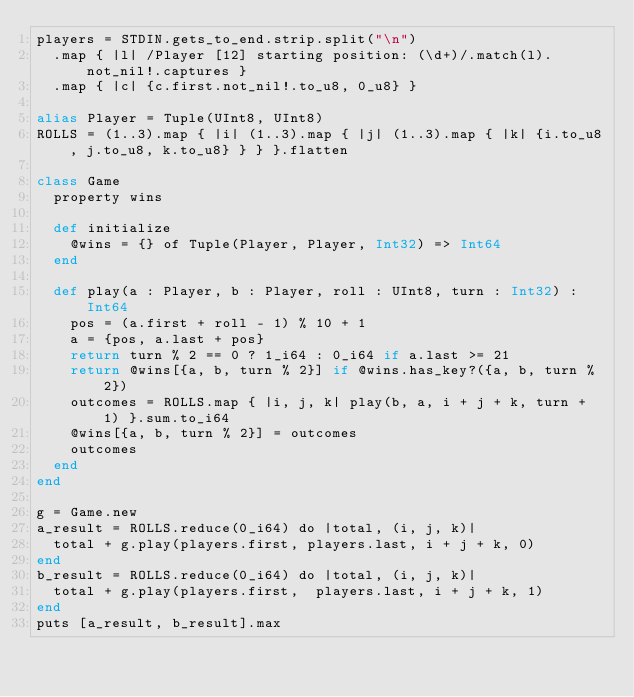Convert code to text. <code><loc_0><loc_0><loc_500><loc_500><_Crystal_>players = STDIN.gets_to_end.strip.split("\n")
  .map { |l| /Player [12] starting position: (\d+)/.match(l).not_nil!.captures }
  .map { |c| {c.first.not_nil!.to_u8, 0_u8} }

alias Player = Tuple(UInt8, UInt8)
ROLLS = (1..3).map { |i| (1..3).map { |j| (1..3).map { |k| {i.to_u8, j.to_u8, k.to_u8} } } }.flatten

class Game
  property wins

  def initialize
    @wins = {} of Tuple(Player, Player, Int32) => Int64
  end

  def play(a : Player, b : Player, roll : UInt8, turn : Int32) : Int64
    pos = (a.first + roll - 1) % 10 + 1
    a = {pos, a.last + pos}
    return turn % 2 == 0 ? 1_i64 : 0_i64 if a.last >= 21
    return @wins[{a, b, turn % 2}] if @wins.has_key?({a, b, turn % 2})
    outcomes = ROLLS.map { |i, j, k| play(b, a, i + j + k, turn + 1) }.sum.to_i64
    @wins[{a, b, turn % 2}] = outcomes
    outcomes
  end
end

g = Game.new
a_result = ROLLS.reduce(0_i64) do |total, (i, j, k)|
  total + g.play(players.first, players.last, i + j + k, 0)
end
b_result = ROLLS.reduce(0_i64) do |total, (i, j, k)|
  total + g.play(players.first,  players.last, i + j + k, 1)
end
puts [a_result, b_result].max
</code> 